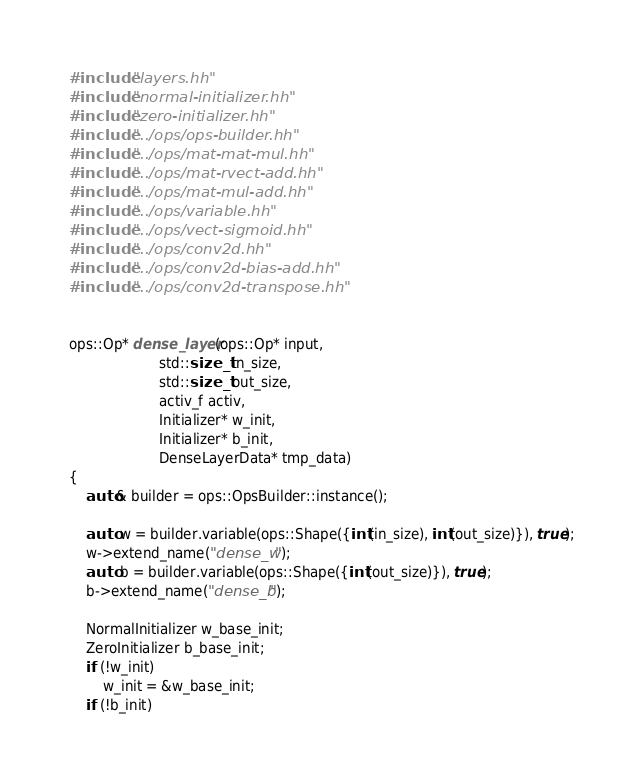<code> <loc_0><loc_0><loc_500><loc_500><_Cuda_>#include "layers.hh"
#include "normal-initializer.hh"
#include "zero-initializer.hh"
#include "../ops/ops-builder.hh"
#include "../ops/mat-mat-mul.hh"
#include "../ops/mat-rvect-add.hh"
#include "../ops/mat-mul-add.hh"
#include "../ops/variable.hh"
#include "../ops/vect-sigmoid.hh"
#include "../ops/conv2d.hh"
#include "../ops/conv2d-bias-add.hh"
#include "../ops/conv2d-transpose.hh"


ops::Op* dense_layer(ops::Op* input,
                     std::size_t in_size,
                     std::size_t out_size,
                     activ_f activ,
                     Initializer* w_init,
                     Initializer* b_init,
                     DenseLayerData* tmp_data)
{
    auto& builder = ops::OpsBuilder::instance();

    auto w = builder.variable(ops::Shape({int(in_size), int(out_size)}), true);
    w->extend_name("dense_w");
    auto b = builder.variable(ops::Shape({int(out_size)}), true);
    b->extend_name("dense_b");

    NormalInitializer w_base_init;
    ZeroInitializer b_base_init;
    if (!w_init)
        w_init = &w_base_init;
    if (!b_init)</code> 